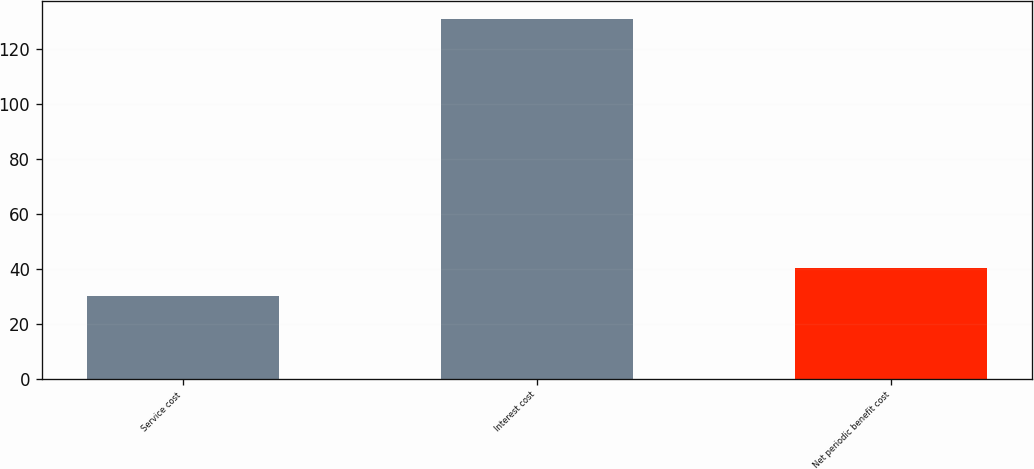Convert chart. <chart><loc_0><loc_0><loc_500><loc_500><bar_chart><fcel>Service cost<fcel>Interest cost<fcel>Net periodic benefit cost<nl><fcel>30<fcel>131<fcel>40.1<nl></chart> 